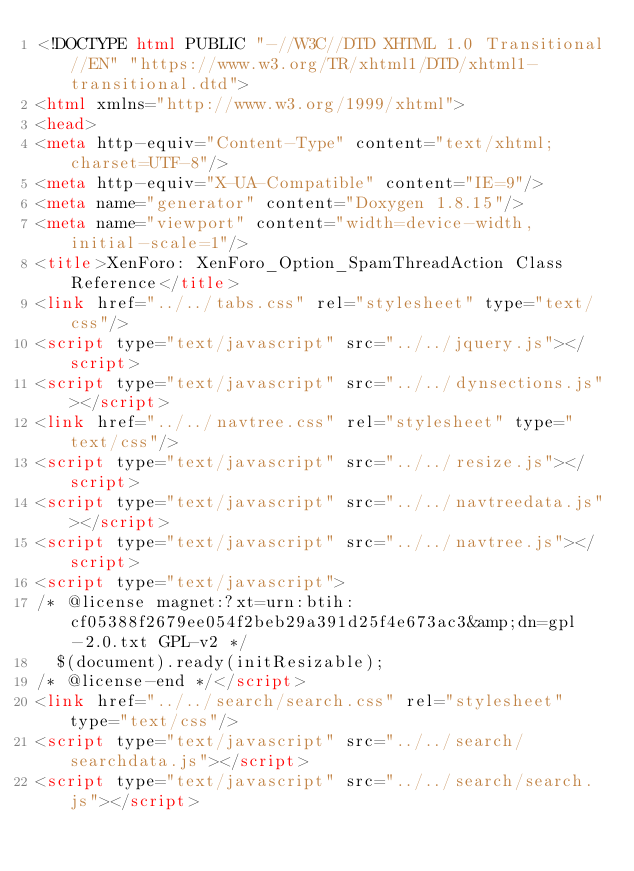Convert code to text. <code><loc_0><loc_0><loc_500><loc_500><_HTML_><!DOCTYPE html PUBLIC "-//W3C//DTD XHTML 1.0 Transitional//EN" "https://www.w3.org/TR/xhtml1/DTD/xhtml1-transitional.dtd">
<html xmlns="http://www.w3.org/1999/xhtml">
<head>
<meta http-equiv="Content-Type" content="text/xhtml;charset=UTF-8"/>
<meta http-equiv="X-UA-Compatible" content="IE=9"/>
<meta name="generator" content="Doxygen 1.8.15"/>
<meta name="viewport" content="width=device-width, initial-scale=1"/>
<title>XenForo: XenForo_Option_SpamThreadAction Class Reference</title>
<link href="../../tabs.css" rel="stylesheet" type="text/css"/>
<script type="text/javascript" src="../../jquery.js"></script>
<script type="text/javascript" src="../../dynsections.js"></script>
<link href="../../navtree.css" rel="stylesheet" type="text/css"/>
<script type="text/javascript" src="../../resize.js"></script>
<script type="text/javascript" src="../../navtreedata.js"></script>
<script type="text/javascript" src="../../navtree.js"></script>
<script type="text/javascript">
/* @license magnet:?xt=urn:btih:cf05388f2679ee054f2beb29a391d25f4e673ac3&amp;dn=gpl-2.0.txt GPL-v2 */
  $(document).ready(initResizable);
/* @license-end */</script>
<link href="../../search/search.css" rel="stylesheet" type="text/css"/>
<script type="text/javascript" src="../../search/searchdata.js"></script>
<script type="text/javascript" src="../../search/search.js"></script></code> 